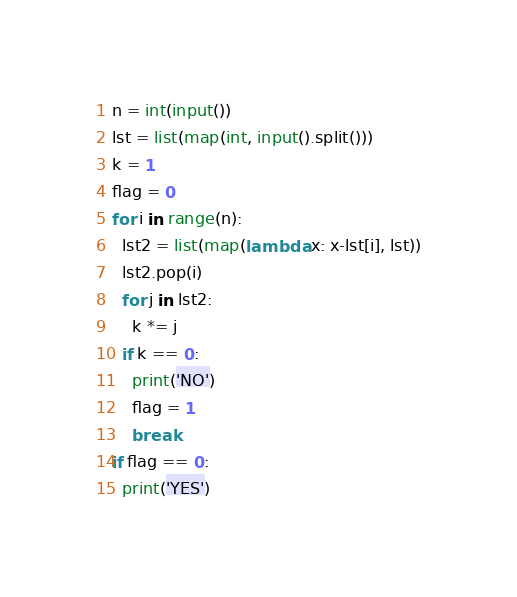<code> <loc_0><loc_0><loc_500><loc_500><_Python_>n = int(input())
lst = list(map(int, input().split()))
k = 1
flag = 0
for i in range(n):
  lst2 = list(map(lambda x: x-lst[i], lst))
  lst2.pop(i)
  for j in lst2:
    k *= j
  if k == 0:
    print('NO')
    flag = 1
    break
if flag == 0:
  print('YES')</code> 